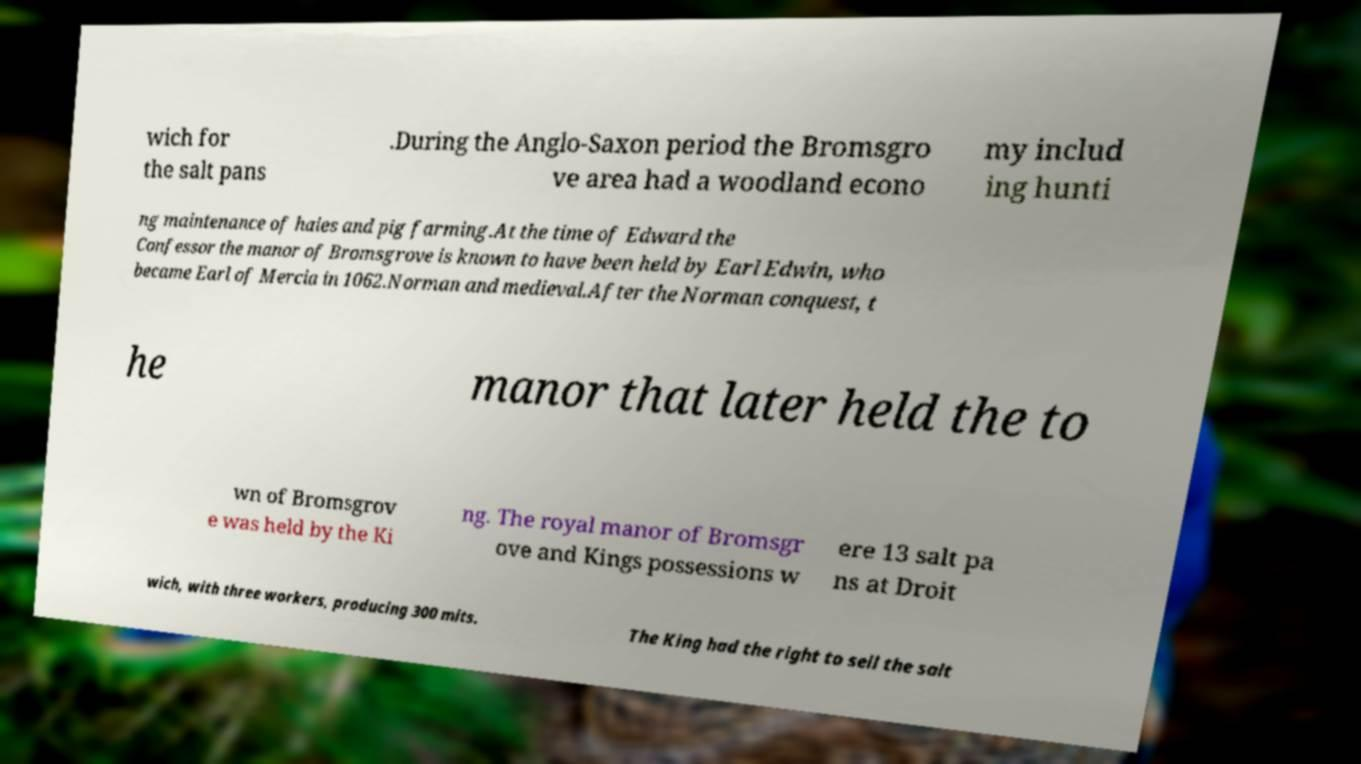Please read and relay the text visible in this image. What does it say? wich for the salt pans .During the Anglo-Saxon period the Bromsgro ve area had a woodland econo my includ ing hunti ng maintenance of haies and pig farming.At the time of Edward the Confessor the manor of Bromsgrove is known to have been held by Earl Edwin, who became Earl of Mercia in 1062.Norman and medieval.After the Norman conquest, t he manor that later held the to wn of Bromsgrov e was held by the Ki ng. The royal manor of Bromsgr ove and Kings possessions w ere 13 salt pa ns at Droit wich, with three workers, producing 300 mits. The King had the right to sell the salt 